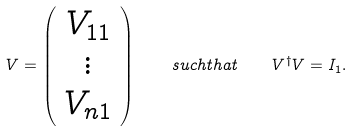<formula> <loc_0><loc_0><loc_500><loc_500>V = \left ( \begin{array} { c } V _ { 1 1 } \\ \vdots \\ V _ { n 1 } \end{array} \right ) \quad s u c h t h a t \quad V ^ { \dagger } V = I _ { 1 } .</formula> 